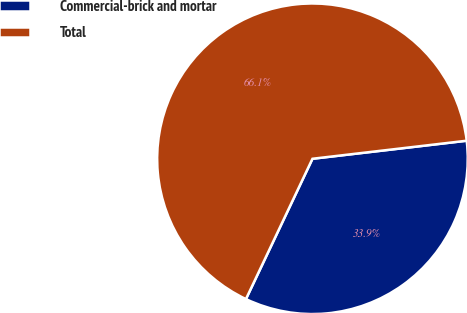Convert chart to OTSL. <chart><loc_0><loc_0><loc_500><loc_500><pie_chart><fcel>Commercial-brick and mortar<fcel>Total<nl><fcel>33.9%<fcel>66.1%<nl></chart> 